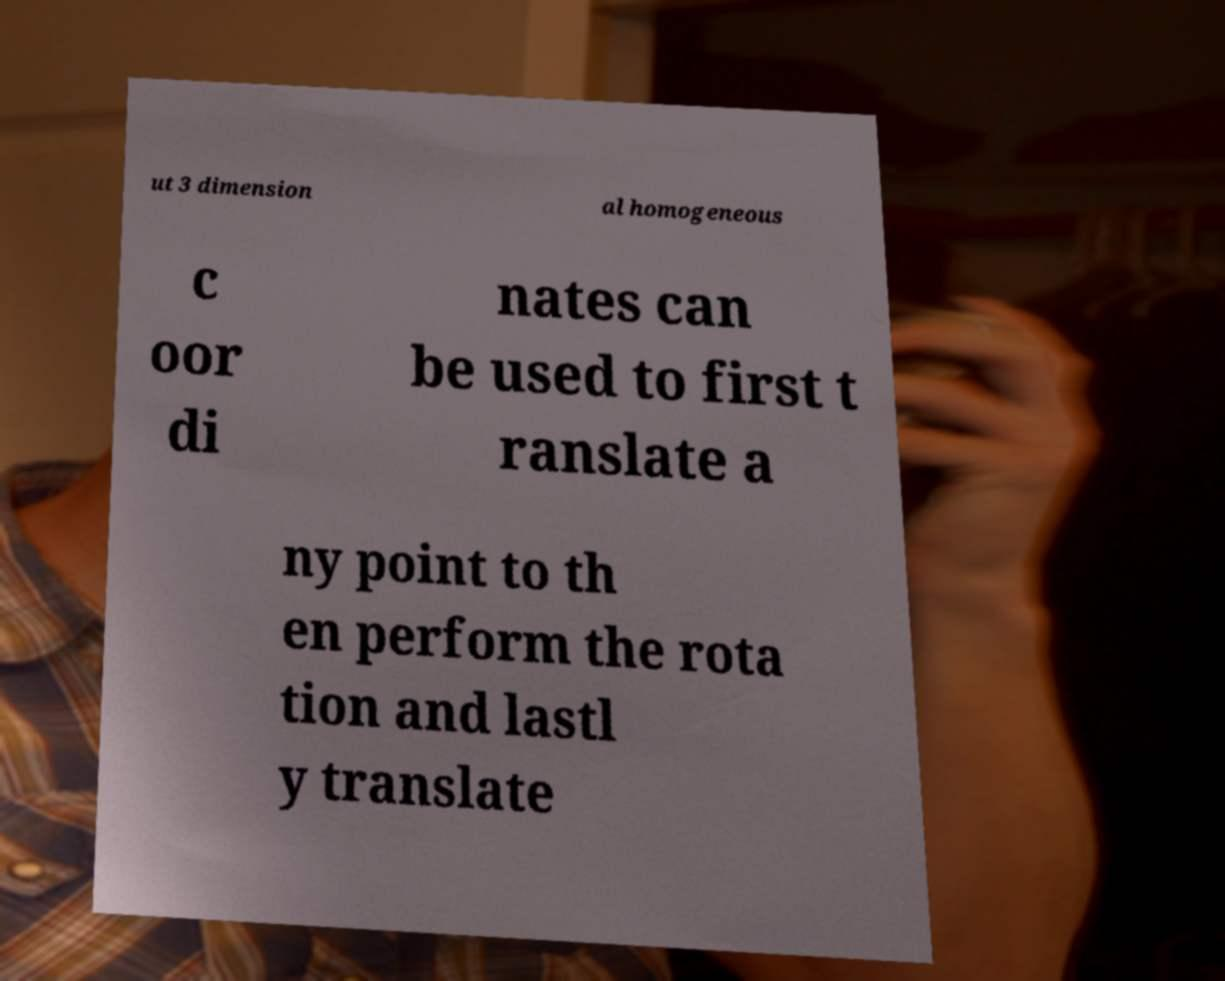Can you read and provide the text displayed in the image?This photo seems to have some interesting text. Can you extract and type it out for me? ut 3 dimension al homogeneous c oor di nates can be used to first t ranslate a ny point to th en perform the rota tion and lastl y translate 